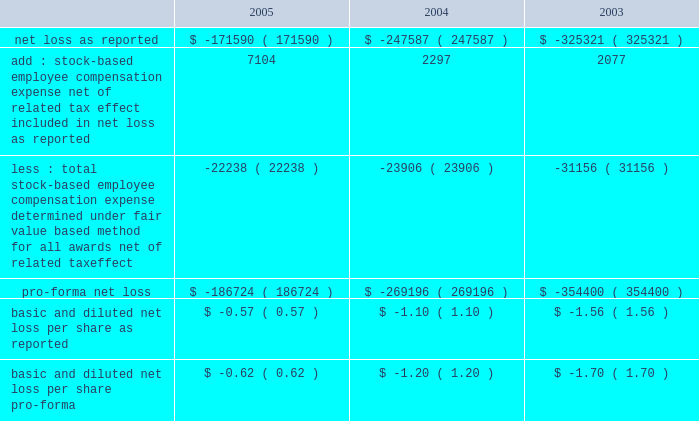American tower corporation and subsidiaries notes to consolidated financial statements 2014 ( continued ) sfas no .
148 .
In accordance with apb no .
25 , the company recognizes compensation expense based on the excess , if any , of the quoted stock price at the grant date of the award or other measurement date over the amount an employee must pay to acquire the stock .
The company 2019s stock option plans are more fully described in note 14 .
In december 2004 , the fasb issued sfas no .
123 ( revised 2004 ) , 201cshare-based payment 201d ( sfas 123r ) , as further described below .
During the year ended december 31 , 2005 , the company reevaluated the assumptions used to estimate the fair value of stock options issued to employees .
As a result , the company lowered its expected volatility assumption for options granted after july 1 , 2005 to approximately 30% ( 30 % ) and increased the expected life of option grants to 6.25 years using the simplified method permitted by sec sab no .
107 , 201dshare-based payment 201d ( sab no .
107 ) .
The company made this change based on a number of factors , including the company 2019s execution of its strategic plans to sell non-core businesses , reduce leverage and refinance its debt , and its recent merger with spectrasite , inc .
( see note 2. ) management had previously based its volatility assumptions on historical volatility since inception , which included periods when the company 2019s capital structure was more highly leveraged than current levels and expected levels for the foreseeable future .
Management 2019s estimate of future volatility is based on its consideration of all available information , including historical volatility , implied volatility of publicly traded options , the company 2019s current capital structure and its publicly announced future business plans .
For comparative purposes , a 10% ( 10 % ) change in the volatility assumption would change pro forma stock option expense and pro forma net loss by approximately $ 0.1 million for the year ended december 31 , 2005 .
( see note 14. ) the table illustrates the effect on net loss and net loss per common share if the company had applied the fair value recognition provisions of sfas no .
123 ( as amended ) to stock-based compensation .
The estimated fair value of each option is calculated using the black-scholes option-pricing model ( in thousands , except per share amounts ) : .
The company has modified certain option awards to revise vesting and exercise terms for certain terminated employees and recognized charges of $ 7.0 million , $ 3.0 million and $ 2.3 million for the years ended december 31 , 2005 , 2004 and 2003 , respectively .
In addition , the stock-based employee compensation amounts above for the year ended december 31 , 2005 , include approximately $ 2.4 million of unearned compensation amortization related to unvested stock options assumed in the merger with spectrasite , inc .
Such charges are reflected in impairments , net loss on sale of long-lived assets , restructuring and merger related expense with corresponding adjustments to additional paid-in capital and unearned compensation in the accompanying consolidated financial statements .
Recent accounting pronouncements 2014in december 2004 , the fasb issued sfas 123r , which supersedes apb no .
25 , and amends sfas no .
95 , 201cstatement of cash flows . 201d this statement addressed the accounting for share-based payments to employees , including grants of employee stock options .
Under the new standard .
What was the percentage decrease in the pro-forma net loss? 
Computations: ((-186724 - -269196) / -269196)
Answer: -0.30636. 